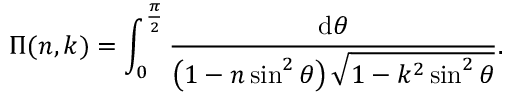<formula> <loc_0><loc_0><loc_500><loc_500>\Pi ( n , k ) = \int _ { 0 } ^ { \frac { \pi } { 2 } } { \frac { d \theta } { \left ( 1 - n \sin ^ { 2 } \theta \right ) { \sqrt { 1 - k ^ { 2 } \sin ^ { 2 } \theta } } } } .</formula> 